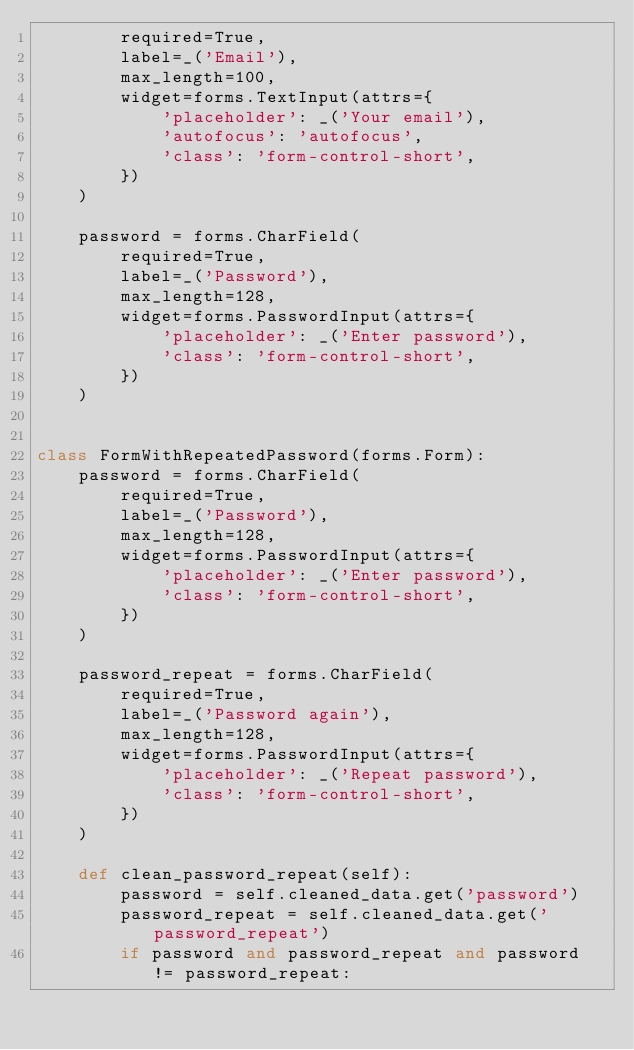<code> <loc_0><loc_0><loc_500><loc_500><_Python_>        required=True,
        label=_('Email'),
        max_length=100,
        widget=forms.TextInput(attrs={
            'placeholder': _('Your email'),
            'autofocus': 'autofocus',
            'class': 'form-control-short',
        })
    )

    password = forms.CharField(
        required=True,
        label=_('Password'),
        max_length=128,
        widget=forms.PasswordInput(attrs={
            'placeholder': _('Enter password'),
            'class': 'form-control-short',
        })
    )


class FormWithRepeatedPassword(forms.Form):
    password = forms.CharField(
        required=True,
        label=_('Password'),
        max_length=128,
        widget=forms.PasswordInput(attrs={
            'placeholder': _('Enter password'),
            'class': 'form-control-short',
        })
    )

    password_repeat = forms.CharField(
        required=True,
        label=_('Password again'),
        max_length=128,
        widget=forms.PasswordInput(attrs={
            'placeholder': _('Repeat password'),
            'class': 'form-control-short',
        })
    )

    def clean_password_repeat(self):
        password = self.cleaned_data.get('password')
        password_repeat = self.cleaned_data.get('password_repeat')
        if password and password_repeat and password != password_repeat:</code> 